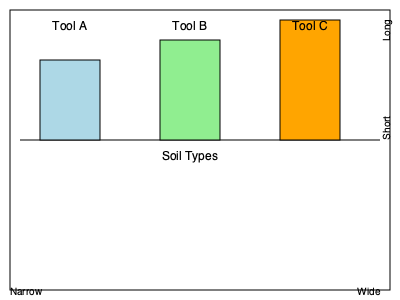Based on the diagram showing three different tree-planting tools (A, B, and C) and their effectiveness in various soil types, which tool would be most suitable for planting trees in a predominantly clay soil environment? To determine the most suitable tool for planting trees in clay soil, we need to analyze the characteristics of clay soil and the properties of the tools shown in the diagram:

1. Clay soil characteristics:
   - Dense and compact
   - Retains water and nutrients well
   - Can be difficult to work with due to its heavy nature

2. Tool requirements for clay soil:
   - Longer to penetrate the dense soil
   - Wider to create adequate space for roots

3. Analysis of tools:
   - Tool A: Short and narrow, suitable for sandy soil
   - Tool B: Medium length and width, suitable for loamy soil
   - Tool C: Long and wide, suitable for clay soil

4. Effectiveness in clay soil:
   - The diagram shows Tool C as the tallest and widest option
   - Tool C's bar extends the furthest into the "Clay" soil type section

5. Conclusion:
   Tool C's longer length will allow for better penetration of the dense clay soil, while its wider design will create more space for root development in the compact environment.
Answer: Tool C 